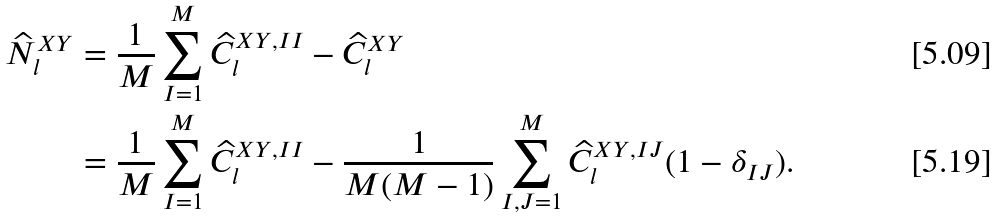Convert formula to latex. <formula><loc_0><loc_0><loc_500><loc_500>\widehat { N } ^ { X Y } _ { l } & = \frac { 1 } { M } \sum ^ { M } _ { I = 1 } \widehat { C } ^ { X Y , I I } _ { l } - \widehat { C } ^ { X Y } _ { l } \\ & = \frac { 1 } { M } \sum ^ { M } _ { I = 1 } \widehat { C } ^ { X Y , I I } _ { l } - \frac { 1 } { M ( M - 1 ) } \sum ^ { M } _ { I , J = 1 } \widehat { C } ^ { X Y , I J } _ { l } ( 1 - \delta _ { I J } ) .</formula> 